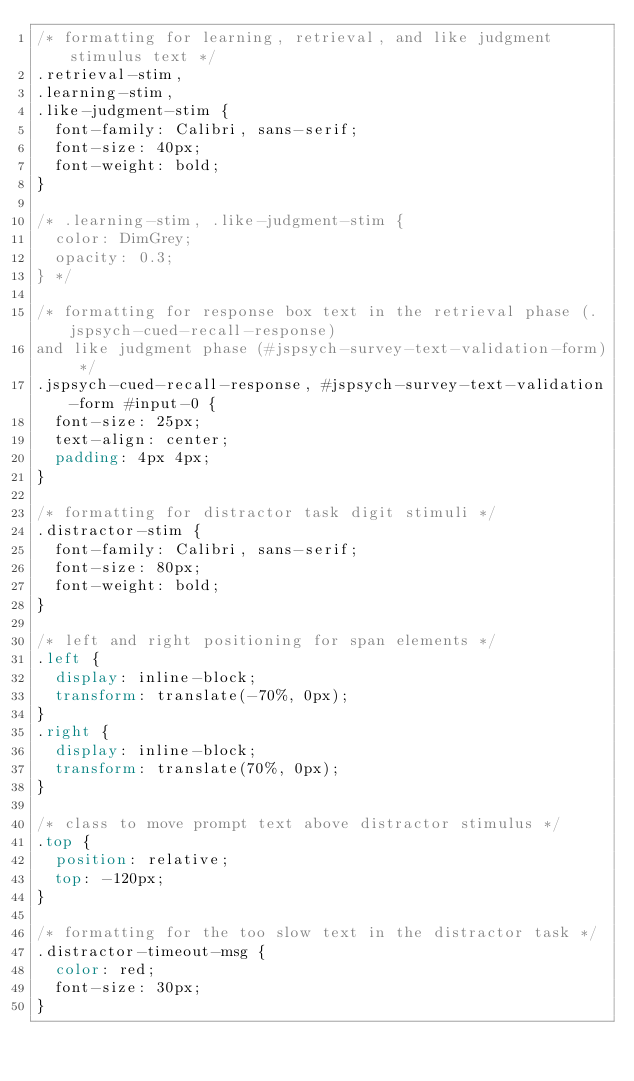Convert code to text. <code><loc_0><loc_0><loc_500><loc_500><_CSS_>/* formatting for learning, retrieval, and like judgment stimulus text */
.retrieval-stim,
.learning-stim,
.like-judgment-stim {
  font-family: Calibri, sans-serif;
  font-size: 40px;
  font-weight: bold;
}

/* .learning-stim, .like-judgment-stim {
  color: DimGrey;
  opacity: 0.3;
} */

/* formatting for response box text in the retrieval phase (.jspsych-cued-recall-response) 
and like judgment phase (#jspsych-survey-text-validation-form) */
.jspsych-cued-recall-response, #jspsych-survey-text-validation-form #input-0 {
  font-size: 25px;
  text-align: center;
  padding: 4px 4px;
}

/* formatting for distractor task digit stimuli */
.distractor-stim {
  font-family: Calibri, sans-serif;
  font-size: 80px;
  font-weight: bold;
}

/* left and right positioning for span elements */
.left {
  display: inline-block;
  transform: translate(-70%, 0px);
}
.right {
  display: inline-block;
  transform: translate(70%, 0px);
}

/* class to move prompt text above distractor stimulus */
.top {
  position: relative;
  top: -120px;
}

/* formatting for the too slow text in the distractor task */
.distractor-timeout-msg {
  color: red;
  font-size: 30px;
}</code> 